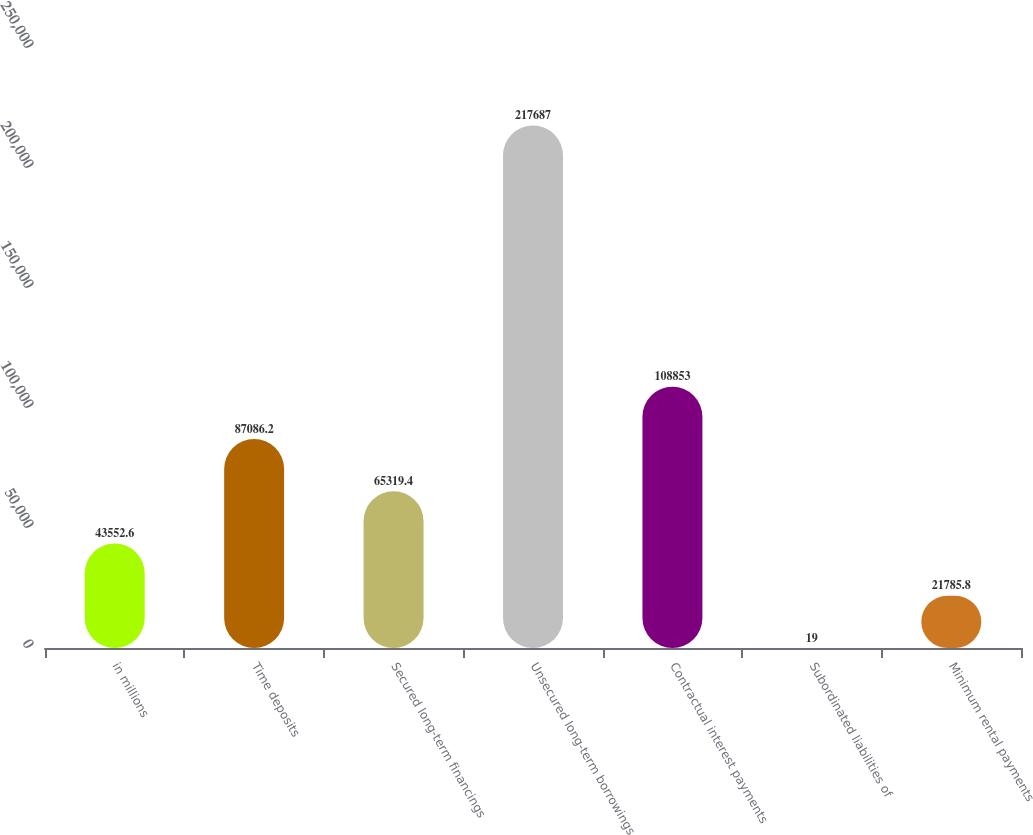Convert chart to OTSL. <chart><loc_0><loc_0><loc_500><loc_500><bar_chart><fcel>in millions<fcel>Time deposits<fcel>Secured long-term financings<fcel>Unsecured long-term borrowings<fcel>Contractual interest payments<fcel>Subordinated liabilities of<fcel>Minimum rental payments<nl><fcel>43552.6<fcel>87086.2<fcel>65319.4<fcel>217687<fcel>108853<fcel>19<fcel>21785.8<nl></chart> 